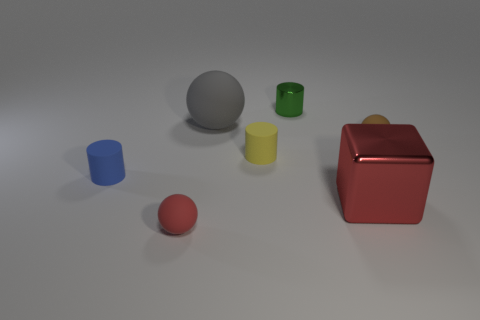Add 2 large purple shiny cylinders. How many objects exist? 9 Subtract all red spheres. How many spheres are left? 2 Subtract all yellow cylinders. How many cylinders are left? 2 Subtract 1 cubes. How many cubes are left? 0 Subtract all gray blocks. Subtract all brown balls. How many blocks are left? 1 Subtract all red cubes. How many red balls are left? 1 Subtract all tiny cyan spheres. Subtract all cylinders. How many objects are left? 4 Add 4 red shiny blocks. How many red shiny blocks are left? 5 Add 5 yellow cylinders. How many yellow cylinders exist? 6 Subtract 0 green balls. How many objects are left? 7 